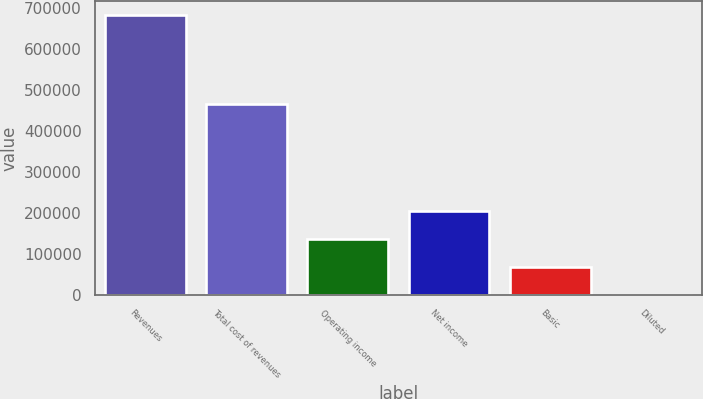Convert chart to OTSL. <chart><loc_0><loc_0><loc_500><loc_500><bar_chart><fcel>Revenues<fcel>Total cost of revenues<fcel>Operating income<fcel>Net income<fcel>Basic<fcel>Diluted<nl><fcel>682213<fcel>465775<fcel>136443<fcel>204664<fcel>68221.9<fcel>0.64<nl></chart> 